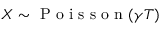<formula> <loc_0><loc_0><loc_500><loc_500>X \sim P o i s s o n ( \gamma T )</formula> 